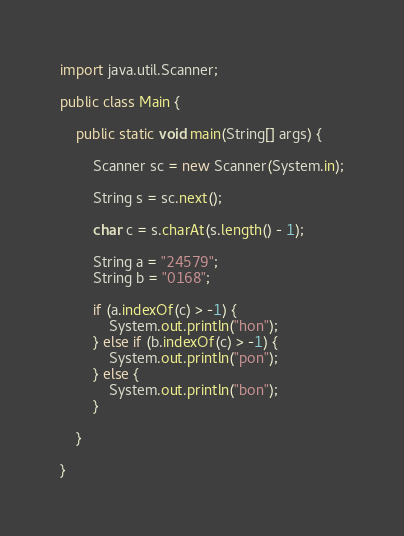Convert code to text. <code><loc_0><loc_0><loc_500><loc_500><_Java_>import java.util.Scanner;

public class Main {

	public static void main(String[] args) {

		Scanner sc = new Scanner(System.in);

		String s = sc.next();

		char c = s.charAt(s.length() - 1);

		String a = "24579";
		String b = "0168";

		if (a.indexOf(c) > -1) {
			System.out.println("hon");
		} else if (b.indexOf(c) > -1) {
			System.out.println("pon");
		} else {
			System.out.println("bon");
		}

	}

}</code> 